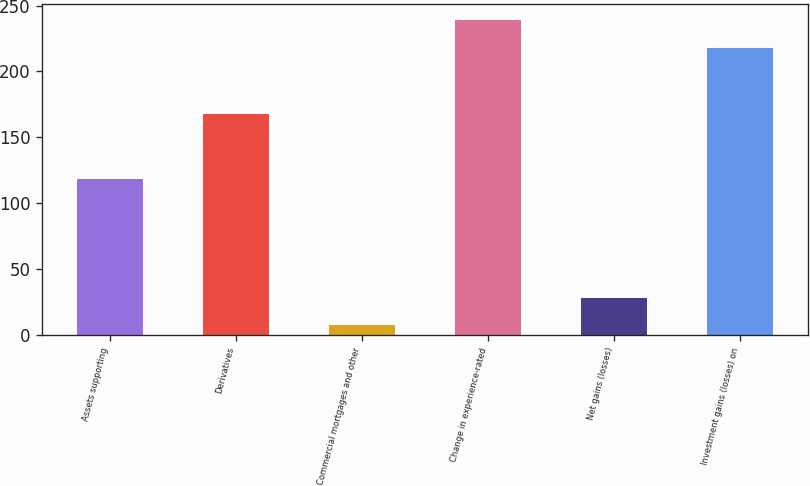Convert chart to OTSL. <chart><loc_0><loc_0><loc_500><loc_500><bar_chart><fcel>Assets supporting<fcel>Derivatives<fcel>Commercial mortgages and other<fcel>Change in experience-rated<fcel>Net gains (losses)<fcel>Investment gains (losses) on<nl><fcel>118<fcel>168<fcel>7<fcel>239.1<fcel>28.1<fcel>218<nl></chart> 